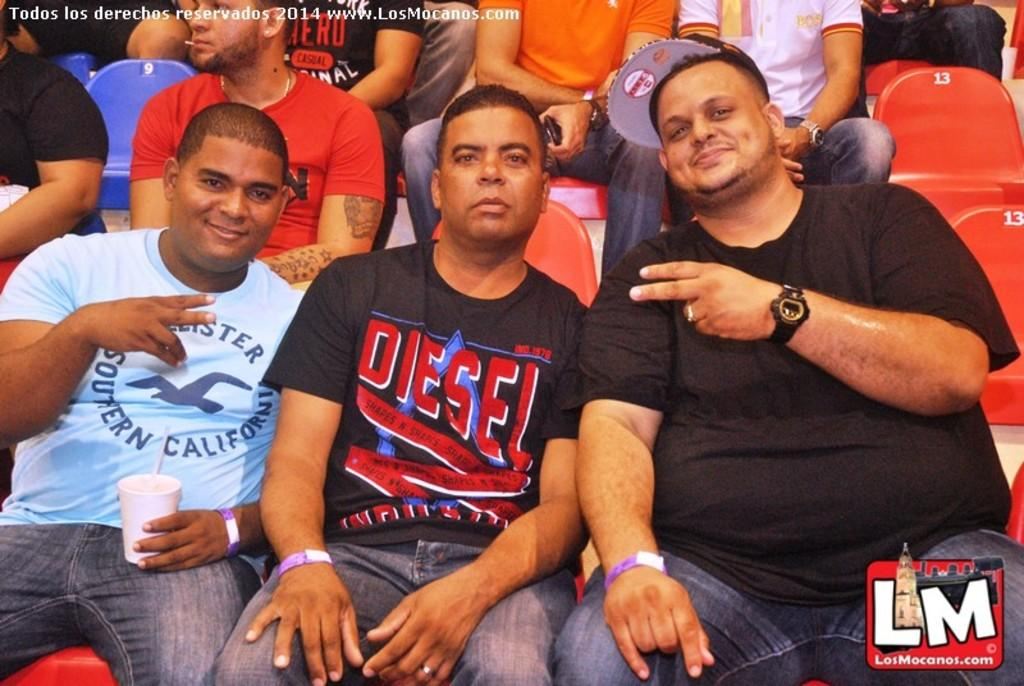What are the people in the image doing? The people in the image are sitting on chairs. What is the man holding in the image? The man is holding a cup in the image. Can you describe any additional features of the image? There is a watermark in the top left corner of the image. Can you see any planes flying in the image? There are no planes visible in the image. Are there any people swimming in the image? There is no indication of swimming or a swimming pool in the image. 